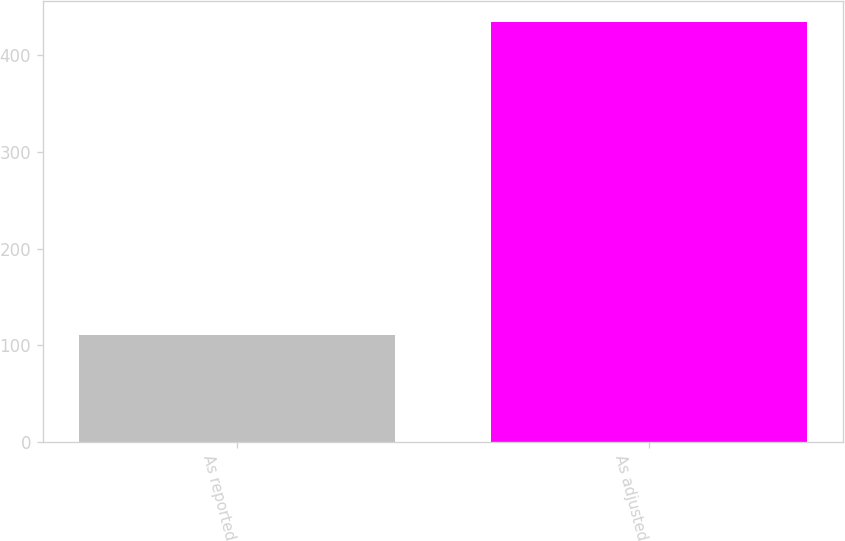Convert chart to OTSL. <chart><loc_0><loc_0><loc_500><loc_500><bar_chart><fcel>As reported<fcel>As adjusted<nl><fcel>110.6<fcel>434.8<nl></chart> 